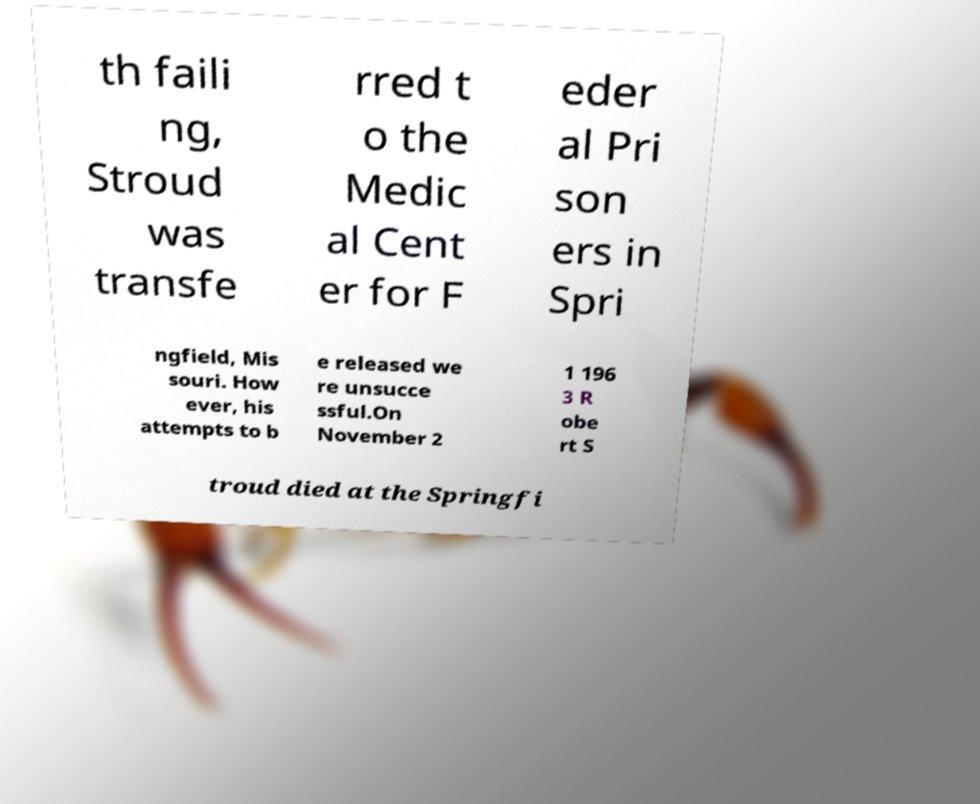I need the written content from this picture converted into text. Can you do that? th faili ng, Stroud was transfe rred t o the Medic al Cent er for F eder al Pri son ers in Spri ngfield, Mis souri. How ever, his attempts to b e released we re unsucce ssful.On November 2 1 196 3 R obe rt S troud died at the Springfi 